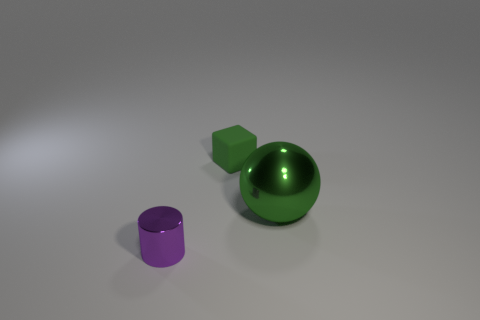Are there more large green things behind the purple metallic object than big green metallic things to the left of the big thing?
Your response must be concise. Yes. What color is the metallic object that is right of the thing behind the large shiny sphere?
Your response must be concise. Green. Are there any small things of the same color as the large object?
Provide a short and direct response. Yes. There is a metallic object on the right side of the green object that is to the left of the metallic thing behind the cylinder; how big is it?
Your response must be concise. Large. What is the shape of the purple metal object?
Give a very brief answer. Cylinder. The shiny ball that is the same color as the small rubber block is what size?
Your response must be concise. Large. There is a shiny object right of the small shiny object; how many small purple metallic cylinders are in front of it?
Give a very brief answer. 1. How many other objects are there of the same material as the tiny cube?
Make the answer very short. 0. Is the material of the tiny thing that is on the right side of the tiny cylinder the same as the tiny object that is on the left side of the matte block?
Make the answer very short. No. Is there any other thing that is the same shape as the rubber thing?
Your answer should be compact. No. 